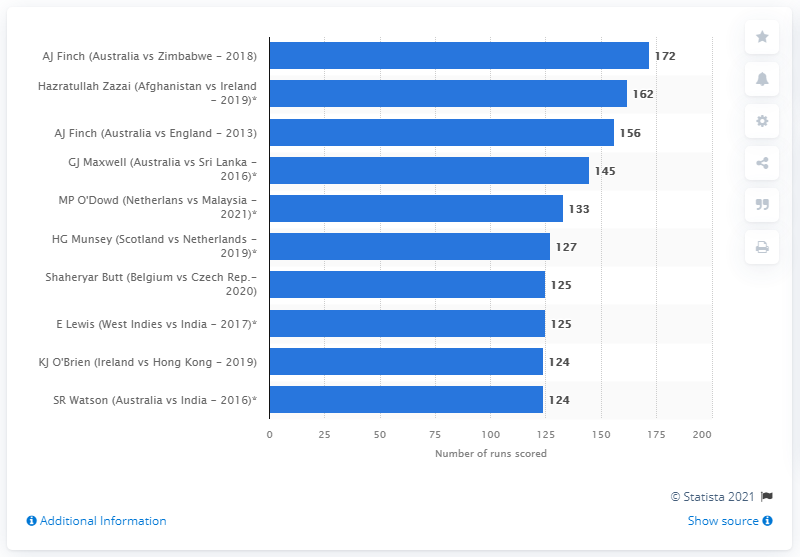Specify some key components in this picture. Aaron Finch set a new record with a score of 172 against Zimbabwe in July 2018. 